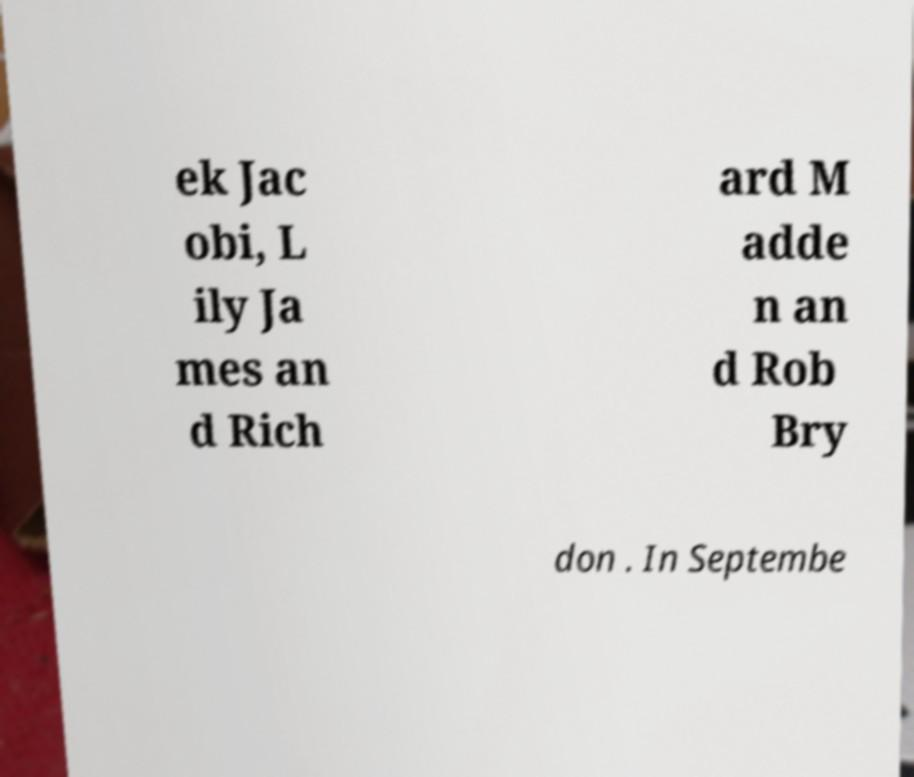There's text embedded in this image that I need extracted. Can you transcribe it verbatim? ek Jac obi, L ily Ja mes an d Rich ard M adde n an d Rob Bry don . In Septembe 